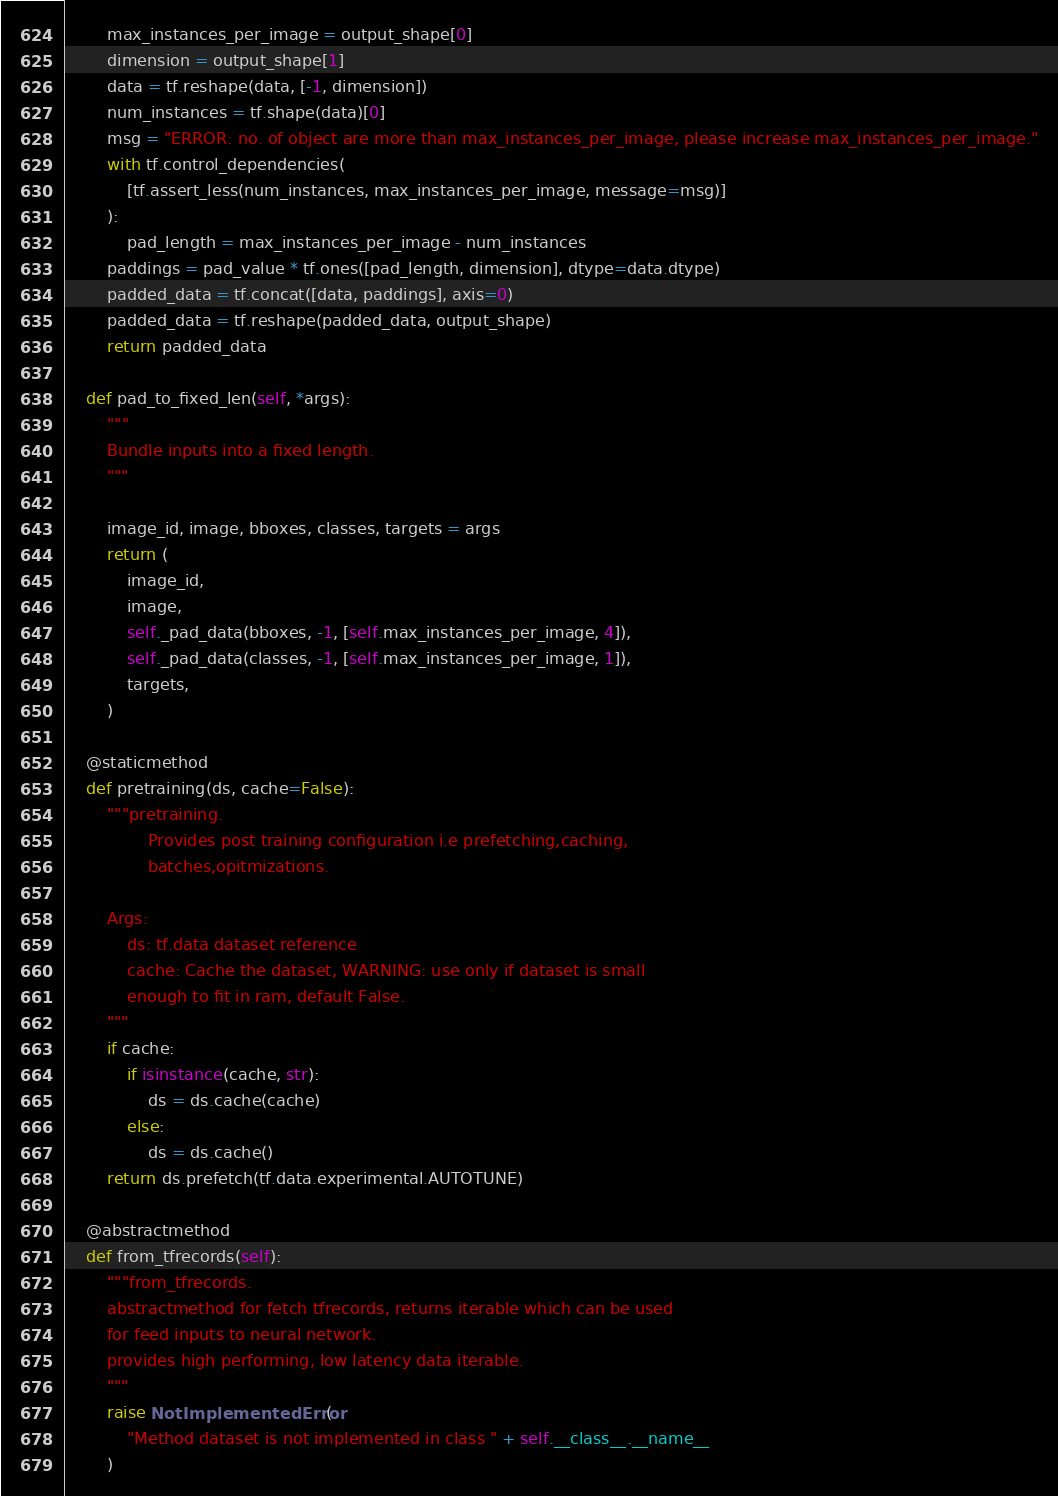<code> <loc_0><loc_0><loc_500><loc_500><_Python_>        max_instances_per_image = output_shape[0]
        dimension = output_shape[1]
        data = tf.reshape(data, [-1, dimension])
        num_instances = tf.shape(data)[0]
        msg = "ERROR: no. of object are more than max_instances_per_image, please increase max_instances_per_image."
        with tf.control_dependencies(
            [tf.assert_less(num_instances, max_instances_per_image, message=msg)]
        ):
            pad_length = max_instances_per_image - num_instances
        paddings = pad_value * tf.ones([pad_length, dimension], dtype=data.dtype)
        padded_data = tf.concat([data, paddings], axis=0)
        padded_data = tf.reshape(padded_data, output_shape)
        return padded_data

    def pad_to_fixed_len(self, *args):
        """
        Bundle inputs into a fixed length.
        """

        image_id, image, bboxes, classes, targets = args
        return (
            image_id,
            image,
            self._pad_data(bboxes, -1, [self.max_instances_per_image, 4]),
            self._pad_data(classes, -1, [self.max_instances_per_image, 1]),
            targets,
        )

    @staticmethod
    def pretraining(ds, cache=False):
        """pretraining.
                Provides post training configuration i.e prefetching,caching,
                batches,opitmizations.

        Args:
            ds: tf.data dataset reference
            cache: Cache the dataset, WARNING: use only if dataset is small
            enough to fit in ram, default False.
        """
        if cache:
            if isinstance(cache, str):
                ds = ds.cache(cache)
            else:
                ds = ds.cache()
        return ds.prefetch(tf.data.experimental.AUTOTUNE)

    @abstractmethod
    def from_tfrecords(self):
        """from_tfrecords.
        abstractmethod for fetch tfrecords, returns iterable which can be used
        for feed inputs to neural network.
        provides high performing, low latency data iterable.
        """
        raise NotImplementedError(
            "Method dataset is not implemented in class " + self.__class__.__name__
        )
</code> 